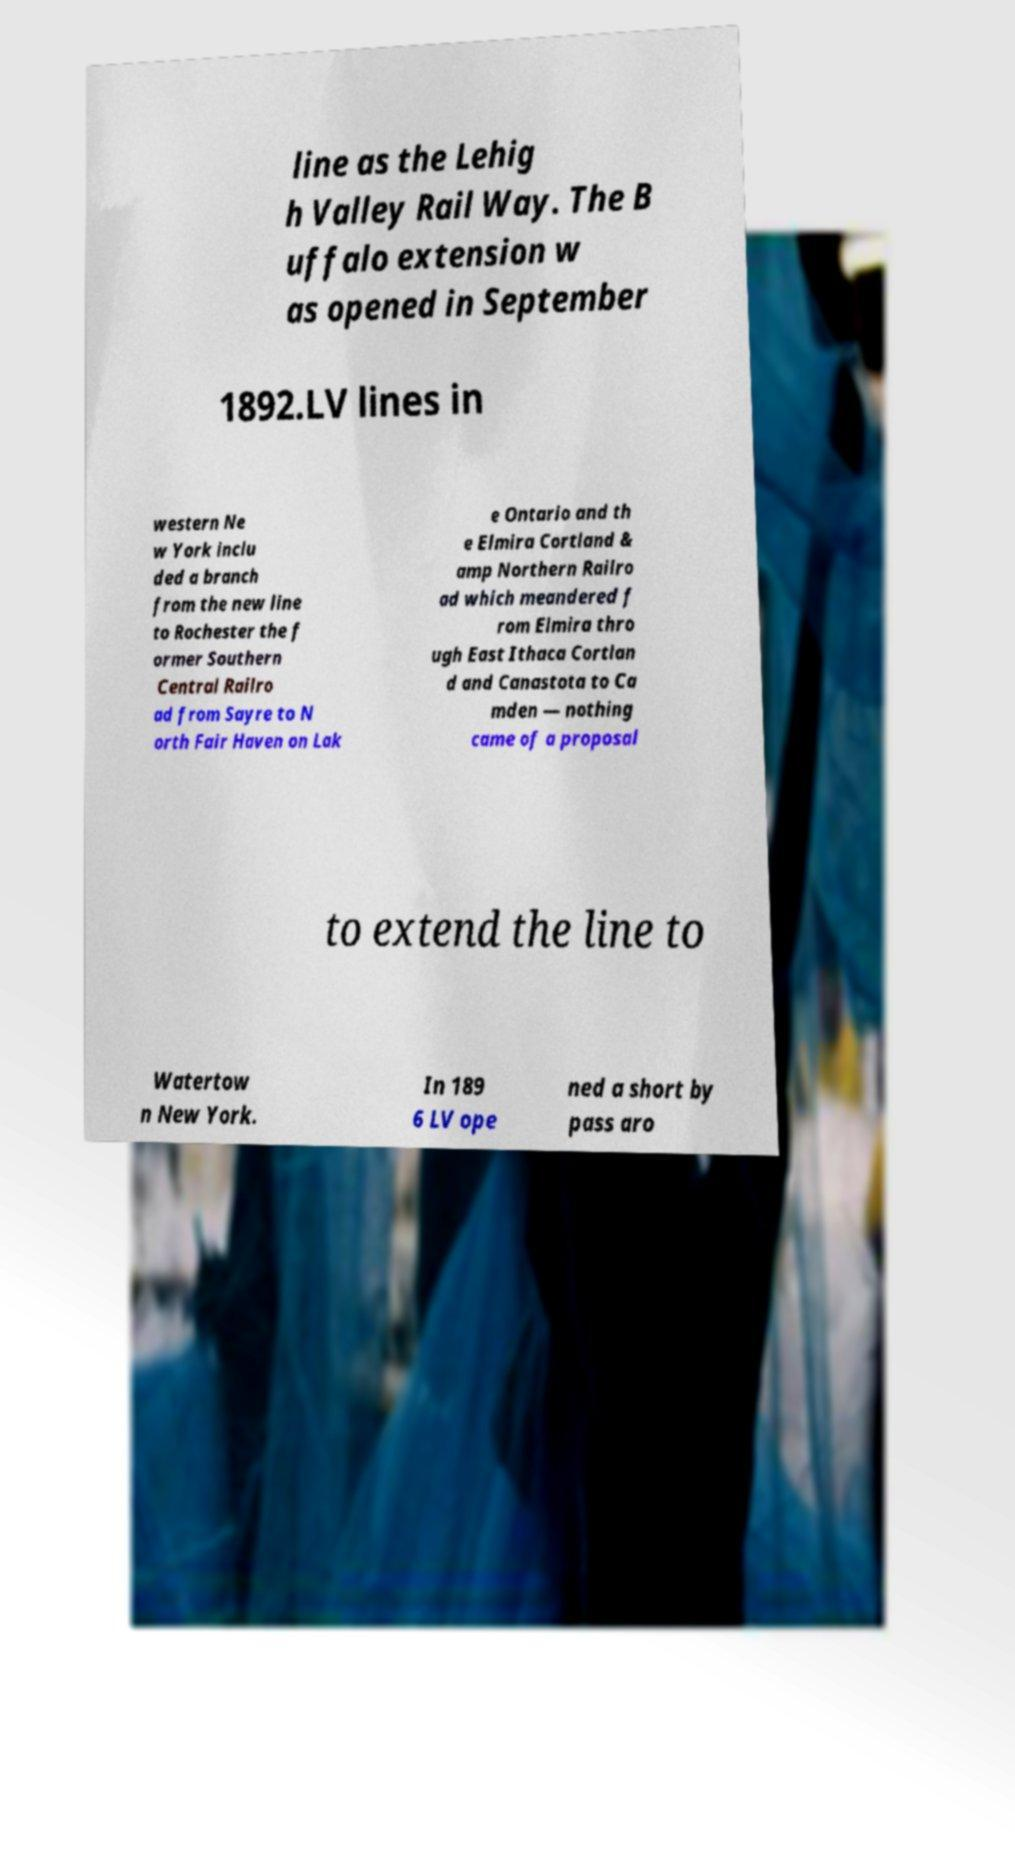Could you assist in decoding the text presented in this image and type it out clearly? line as the Lehig h Valley Rail Way. The B uffalo extension w as opened in September 1892.LV lines in western Ne w York inclu ded a branch from the new line to Rochester the f ormer Southern Central Railro ad from Sayre to N orth Fair Haven on Lak e Ontario and th e Elmira Cortland & amp Northern Railro ad which meandered f rom Elmira thro ugh East Ithaca Cortlan d and Canastota to Ca mden — nothing came of a proposal to extend the line to Watertow n New York. In 189 6 LV ope ned a short by pass aro 